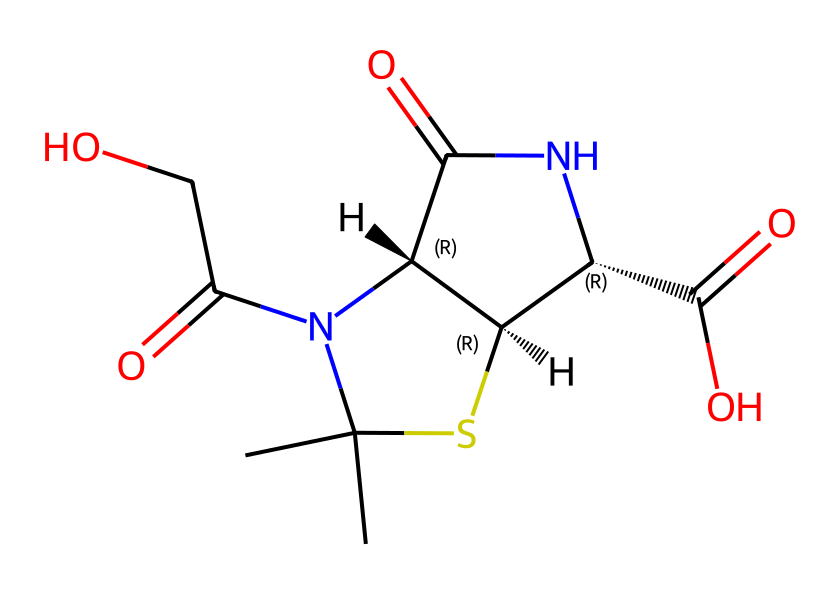What is the molecular formula of this chemical? To determine the molecular formula, count the number of each type of atom present in the SMILES representation. The chemical consists of carbon (C), hydrogen (H), nitrogen (N), oxygen (O), and sulfur (S). By tallying these, we find there are 10 carbon atoms, 13 hydrogen atoms, 4 nitrogen atoms, 5 oxygen atoms, and 1 sulfur atom. Thus, the molecular formula is C10H13N4O5S.
Answer: C10H13N4O5S How many chiral centers are present in this molecule? Chiral centers are typically identified by the presence of a carbon atom bonded to four different groups. Looking at the SMILES, we can identify two chiral centers, indicated by the "@" symbols that denote stereochemistry. Although some carbon atoms in the structure may have identical substituents, only the two marked with "@" qualify as chiral.
Answer: 2 What type of bond primarily connects the atoms in this molecule? The primary connections between the atoms in organic molecules like this one are covalent bonds. In this structure, atoms share electrons, forming strong links that characterize organic compounds. We can confirm this by observing the various atoms and how they are interconnected in the SMILES.
Answer: covalent What functional groups are present in this molecule? By analyzing the structure, we can identify the functional groups that define the chemical properties of this compound. Key functional groups include amides (due to the C(=O)N structure), a carboxylic acid (C(=O)O), and potentially a thiazolidine group from the sulfur atoms. Thus, the main functional groups present are amide and carboxylic acid.
Answer: amide and carboxylic acid What is the role of this chemical in fighting infections? Penicillin is a beta-lactam antibiotic that interferes with bacterial cell wall synthesis. It accomplishes this by binding to proteins involved in the cross-linking of peptidoglycan layers in bacterial cell walls, ultimately leading to cell lysis. The SMILES structure represents this antibiotic, which highlights its function in disrupting bacterial growth.
Answer: disrupts bacterial cell wall synthesis 